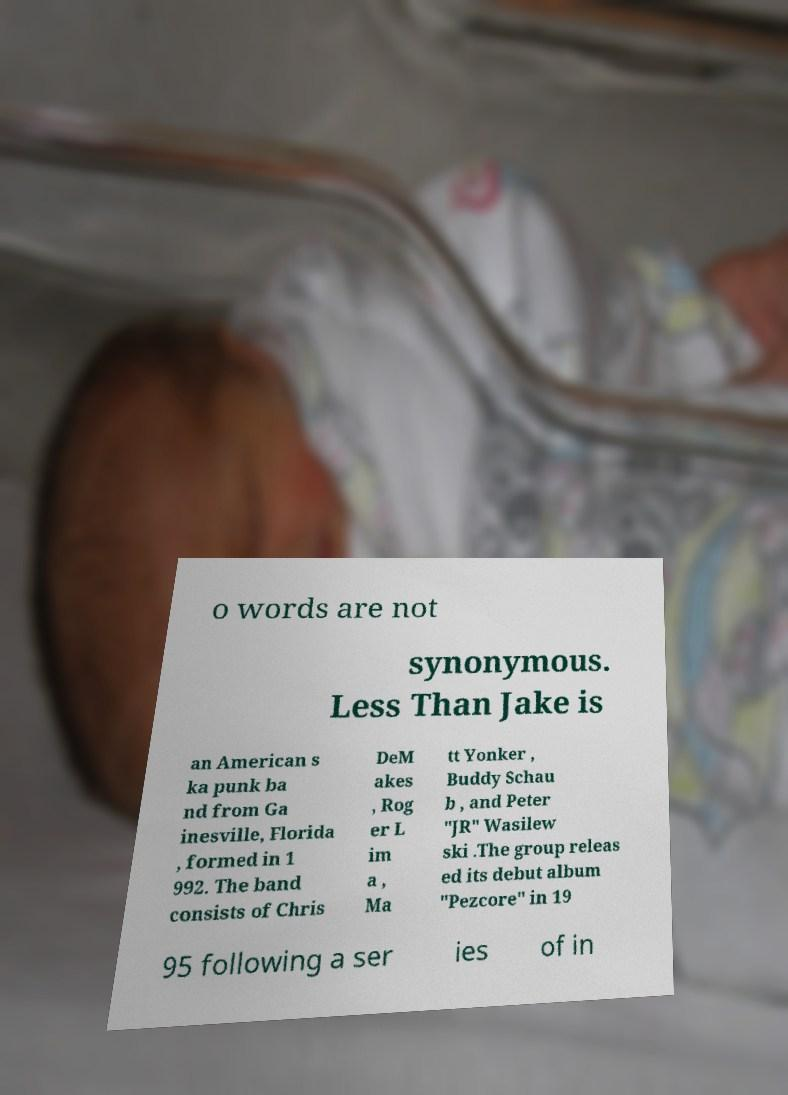Can you read and provide the text displayed in the image?This photo seems to have some interesting text. Can you extract and type it out for me? o words are not synonymous. Less Than Jake is an American s ka punk ba nd from Ga inesville, Florida , formed in 1 992. The band consists of Chris DeM akes , Rog er L im a , Ma tt Yonker , Buddy Schau b , and Peter "JR" Wasilew ski .The group releas ed its debut album "Pezcore" in 19 95 following a ser ies of in 